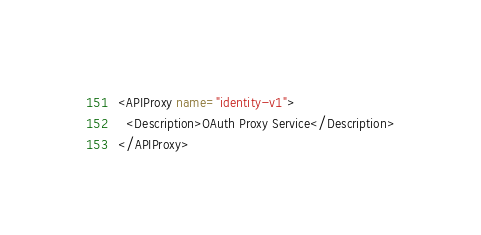Convert code to text. <code><loc_0><loc_0><loc_500><loc_500><_XML_><APIProxy name="identity-v1">
  <Description>OAuth Proxy Service</Description>
</APIProxy>
</code> 